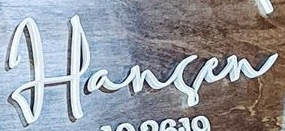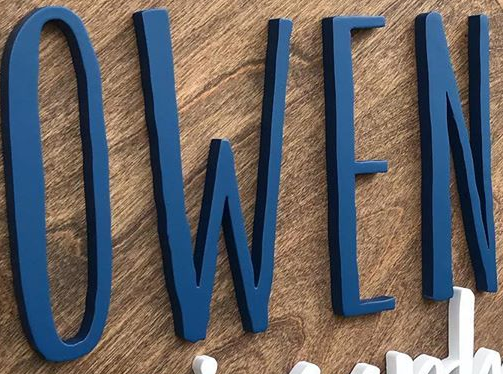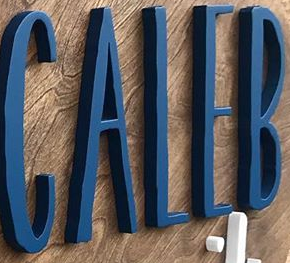Identify the words shown in these images in order, separated by a semicolon. Harsen; OWEN; CALEB 